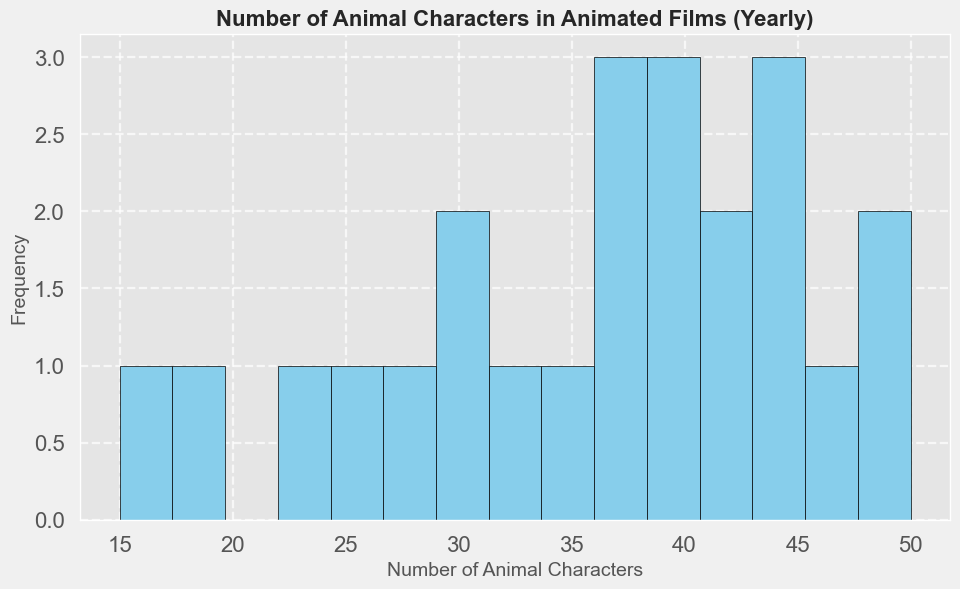What's the most frequent range of the number of animal characters in animated films? To determine the most frequent range, observe which bin (range of values) in the histogram has the highest bar. The bar height represents the frequency of the number of animal characters in that range.
Answer: 40-45 How many years had between 30 and 35 animal characters? Find the bins that represent the ranges from 30 to 35 and count their corresponding bar heights. The heights of the bars within this range represent the frequency of years with 30-35 animal characters.
Answer: 4 years Which year corresponds to the maximum number of animal characters in the histogram? Identify the year with the highest number of animal characters from the given dataset and verify it with the frequency of the highest bin in the histogram.
Answer: 2022 Is the frequency of years with 20-25 animal characters greater than the frequency with 45-50 animal characters? Compare the height of the bars representing 20-25 animal characters with the height of the bars representing 45-50 animal characters. If the bar for 20-25 is higher, then the frequency is greater, and vice versa.
Answer: No What's the range of the number of animal characters for the least frequent bins? Look for the shortest bars in the histogram, which indicate the least frequent ranges of the number of animal characters. The ranges those bins represent are the least frequent ones.
Answer: 15-20 How many bins in total are in the histogram? Count the total number of bars (bins) displayed in the histogram plot. Each bar represents a bin.
Answer: 15 bins Is there a noticeable trend in the number of animal characters in animated films over the years? Observe if the histogram shows a clear pattern, like more bars being taller in the higher number ranges, indicating an increasing trend over the years.
Answer: Yes, increasing What is the average number of animal characters in the most frequent bin? First determine the most frequent bin, which has the highest bar. Calculate the midpoint of that bin's range to find the average number of animal characters in it. For example, if the range is 40-45, the average would be (40+45)/2.
Answer: 42.5 Which bins have a lower frequency than the 25-30 range? Identify the frequency of the bar representing the 25-30 range and compare it to other bins. List the bins with fewer bars (lower frequency).
Answer: 15-20, 20-25 